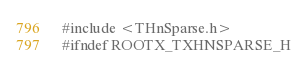Convert code to text. <code><loc_0><loc_0><loc_500><loc_500><_C_>#include <THnSparse.h>
#ifndef ROOTX_TXHNSPARSE_H</code> 